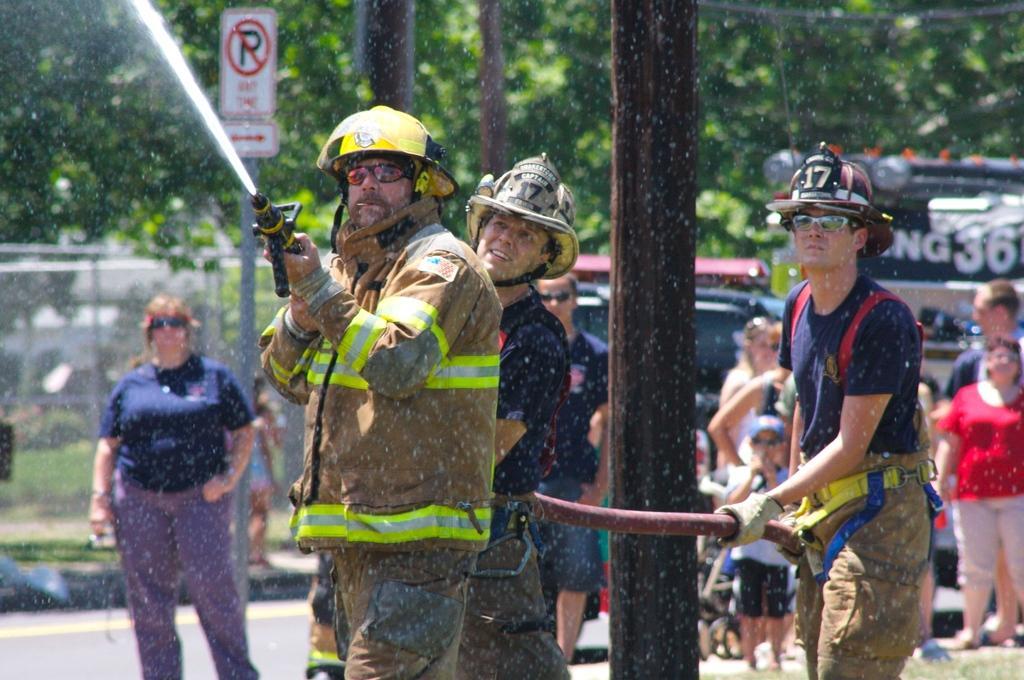Describe this image in one or two sentences. In this picture we can see some people are standing, three persons in the front are wearing helmets, a man in the front is holding a fire fighting water pipe, there is a pole and boards in the middle, in the background there are some trees, it looks like a car in the middle. 